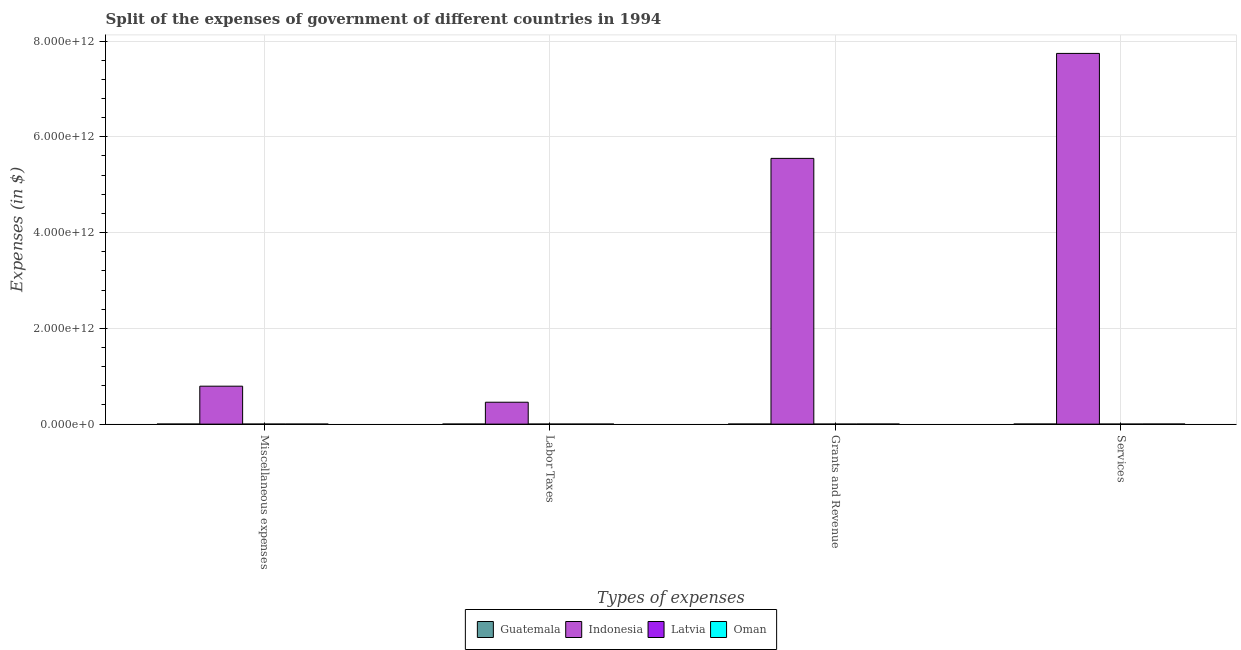How many different coloured bars are there?
Your answer should be compact. 4. How many groups of bars are there?
Offer a very short reply. 4. Are the number of bars per tick equal to the number of legend labels?
Give a very brief answer. Yes. Are the number of bars on each tick of the X-axis equal?
Your answer should be very brief. Yes. What is the label of the 3rd group of bars from the left?
Offer a very short reply. Grants and Revenue. What is the amount spent on grants and revenue in Guatemala?
Your response must be concise. 5.42e+08. Across all countries, what is the maximum amount spent on grants and revenue?
Offer a terse response. 5.55e+12. Across all countries, what is the minimum amount spent on labor taxes?
Offer a terse response. 1.20e+05. In which country was the amount spent on grants and revenue maximum?
Provide a succinct answer. Indonesia. In which country was the amount spent on services minimum?
Provide a short and direct response. Latvia. What is the total amount spent on labor taxes in the graph?
Make the answer very short. 4.57e+11. What is the difference between the amount spent on services in Latvia and that in Indonesia?
Offer a very short reply. -7.74e+12. What is the difference between the amount spent on miscellaneous expenses in Oman and the amount spent on grants and revenue in Guatemala?
Provide a short and direct response. -5.33e+08. What is the average amount spent on miscellaneous expenses per country?
Give a very brief answer. 1.98e+11. What is the difference between the amount spent on grants and revenue and amount spent on labor taxes in Latvia?
Ensure brevity in your answer.  3.44e+07. What is the ratio of the amount spent on services in Indonesia to that in Oman?
Provide a short and direct response. 8257.95. Is the amount spent on miscellaneous expenses in Oman less than that in Indonesia?
Offer a very short reply. Yes. What is the difference between the highest and the second highest amount spent on grants and revenue?
Your answer should be very brief. 5.55e+12. What is the difference between the highest and the lowest amount spent on services?
Your answer should be compact. 7.74e+12. In how many countries, is the amount spent on miscellaneous expenses greater than the average amount spent on miscellaneous expenses taken over all countries?
Ensure brevity in your answer.  1. Is the sum of the amount spent on grants and revenue in Indonesia and Oman greater than the maximum amount spent on miscellaneous expenses across all countries?
Your answer should be compact. Yes. What does the 1st bar from the left in Grants and Revenue represents?
Provide a succinct answer. Guatemala. Is it the case that in every country, the sum of the amount spent on miscellaneous expenses and amount spent on labor taxes is greater than the amount spent on grants and revenue?
Give a very brief answer. No. How many bars are there?
Ensure brevity in your answer.  16. What is the difference between two consecutive major ticks on the Y-axis?
Provide a succinct answer. 2.00e+12. How many legend labels are there?
Give a very brief answer. 4. How are the legend labels stacked?
Provide a short and direct response. Horizontal. What is the title of the graph?
Ensure brevity in your answer.  Split of the expenses of government of different countries in 1994. Does "Venezuela" appear as one of the legend labels in the graph?
Your answer should be compact. No. What is the label or title of the X-axis?
Keep it short and to the point. Types of expenses. What is the label or title of the Y-axis?
Ensure brevity in your answer.  Expenses (in $). What is the Expenses (in $) of Guatemala in Miscellaneous expenses?
Offer a terse response. 4.79e+08. What is the Expenses (in $) in Indonesia in Miscellaneous expenses?
Make the answer very short. 7.92e+11. What is the Expenses (in $) in Latvia in Miscellaneous expenses?
Offer a very short reply. 2.86e+06. What is the Expenses (in $) of Oman in Miscellaneous expenses?
Your response must be concise. 8.50e+06. What is the Expenses (in $) in Guatemala in Labor Taxes?
Provide a short and direct response. 2.20e+08. What is the Expenses (in $) in Indonesia in Labor Taxes?
Offer a terse response. 4.57e+11. What is the Expenses (in $) of Oman in Labor Taxes?
Ensure brevity in your answer.  1.62e+07. What is the Expenses (in $) of Guatemala in Grants and Revenue?
Provide a succinct answer. 5.42e+08. What is the Expenses (in $) in Indonesia in Grants and Revenue?
Provide a short and direct response. 5.55e+12. What is the Expenses (in $) of Latvia in Grants and Revenue?
Your response must be concise. 3.46e+07. What is the Expenses (in $) in Oman in Grants and Revenue?
Give a very brief answer. 1.06e+09. What is the Expenses (in $) of Guatemala in Services?
Offer a very short reply. 8.14e+08. What is the Expenses (in $) in Indonesia in Services?
Keep it short and to the point. 7.74e+12. What is the Expenses (in $) in Latvia in Services?
Offer a terse response. 9.75e+07. What is the Expenses (in $) of Oman in Services?
Provide a short and direct response. 9.37e+08. Across all Types of expenses, what is the maximum Expenses (in $) in Guatemala?
Provide a succinct answer. 8.14e+08. Across all Types of expenses, what is the maximum Expenses (in $) in Indonesia?
Your response must be concise. 7.74e+12. Across all Types of expenses, what is the maximum Expenses (in $) of Latvia?
Make the answer very short. 9.75e+07. Across all Types of expenses, what is the maximum Expenses (in $) of Oman?
Offer a very short reply. 1.06e+09. Across all Types of expenses, what is the minimum Expenses (in $) of Guatemala?
Give a very brief answer. 2.20e+08. Across all Types of expenses, what is the minimum Expenses (in $) of Indonesia?
Make the answer very short. 4.57e+11. Across all Types of expenses, what is the minimum Expenses (in $) of Latvia?
Ensure brevity in your answer.  1.20e+05. Across all Types of expenses, what is the minimum Expenses (in $) in Oman?
Your response must be concise. 8.50e+06. What is the total Expenses (in $) of Guatemala in the graph?
Give a very brief answer. 2.05e+09. What is the total Expenses (in $) of Indonesia in the graph?
Offer a terse response. 1.45e+13. What is the total Expenses (in $) in Latvia in the graph?
Give a very brief answer. 1.35e+08. What is the total Expenses (in $) in Oman in the graph?
Your response must be concise. 2.02e+09. What is the difference between the Expenses (in $) of Guatemala in Miscellaneous expenses and that in Labor Taxes?
Your answer should be very brief. 2.59e+08. What is the difference between the Expenses (in $) of Indonesia in Miscellaneous expenses and that in Labor Taxes?
Ensure brevity in your answer.  3.35e+11. What is the difference between the Expenses (in $) of Latvia in Miscellaneous expenses and that in Labor Taxes?
Ensure brevity in your answer.  2.74e+06. What is the difference between the Expenses (in $) in Oman in Miscellaneous expenses and that in Labor Taxes?
Ensure brevity in your answer.  -7.70e+06. What is the difference between the Expenses (in $) of Guatemala in Miscellaneous expenses and that in Grants and Revenue?
Make the answer very short. -6.28e+07. What is the difference between the Expenses (in $) of Indonesia in Miscellaneous expenses and that in Grants and Revenue?
Keep it short and to the point. -4.76e+12. What is the difference between the Expenses (in $) in Latvia in Miscellaneous expenses and that in Grants and Revenue?
Offer a terse response. -3.17e+07. What is the difference between the Expenses (in $) in Oman in Miscellaneous expenses and that in Grants and Revenue?
Offer a very short reply. -1.05e+09. What is the difference between the Expenses (in $) of Guatemala in Miscellaneous expenses and that in Services?
Your response must be concise. -3.35e+08. What is the difference between the Expenses (in $) of Indonesia in Miscellaneous expenses and that in Services?
Ensure brevity in your answer.  -6.95e+12. What is the difference between the Expenses (in $) in Latvia in Miscellaneous expenses and that in Services?
Make the answer very short. -9.46e+07. What is the difference between the Expenses (in $) in Oman in Miscellaneous expenses and that in Services?
Offer a terse response. -9.29e+08. What is the difference between the Expenses (in $) of Guatemala in Labor Taxes and that in Grants and Revenue?
Give a very brief answer. -3.22e+08. What is the difference between the Expenses (in $) in Indonesia in Labor Taxes and that in Grants and Revenue?
Provide a succinct answer. -5.09e+12. What is the difference between the Expenses (in $) of Latvia in Labor Taxes and that in Grants and Revenue?
Provide a succinct answer. -3.44e+07. What is the difference between the Expenses (in $) of Oman in Labor Taxes and that in Grants and Revenue?
Provide a succinct answer. -1.04e+09. What is the difference between the Expenses (in $) in Guatemala in Labor Taxes and that in Services?
Ensure brevity in your answer.  -5.94e+08. What is the difference between the Expenses (in $) of Indonesia in Labor Taxes and that in Services?
Keep it short and to the point. -7.28e+12. What is the difference between the Expenses (in $) in Latvia in Labor Taxes and that in Services?
Your response must be concise. -9.74e+07. What is the difference between the Expenses (in $) in Oman in Labor Taxes and that in Services?
Offer a very short reply. -9.21e+08. What is the difference between the Expenses (in $) in Guatemala in Grants and Revenue and that in Services?
Give a very brief answer. -2.72e+08. What is the difference between the Expenses (in $) of Indonesia in Grants and Revenue and that in Services?
Your response must be concise. -2.19e+12. What is the difference between the Expenses (in $) of Latvia in Grants and Revenue and that in Services?
Keep it short and to the point. -6.29e+07. What is the difference between the Expenses (in $) in Oman in Grants and Revenue and that in Services?
Your answer should be very brief. 1.19e+08. What is the difference between the Expenses (in $) of Guatemala in Miscellaneous expenses and the Expenses (in $) of Indonesia in Labor Taxes?
Make the answer very short. -4.57e+11. What is the difference between the Expenses (in $) in Guatemala in Miscellaneous expenses and the Expenses (in $) in Latvia in Labor Taxes?
Your answer should be very brief. 4.79e+08. What is the difference between the Expenses (in $) of Guatemala in Miscellaneous expenses and the Expenses (in $) of Oman in Labor Taxes?
Provide a succinct answer. 4.63e+08. What is the difference between the Expenses (in $) in Indonesia in Miscellaneous expenses and the Expenses (in $) in Latvia in Labor Taxes?
Your response must be concise. 7.92e+11. What is the difference between the Expenses (in $) of Indonesia in Miscellaneous expenses and the Expenses (in $) of Oman in Labor Taxes?
Offer a terse response. 7.92e+11. What is the difference between the Expenses (in $) of Latvia in Miscellaneous expenses and the Expenses (in $) of Oman in Labor Taxes?
Give a very brief answer. -1.33e+07. What is the difference between the Expenses (in $) of Guatemala in Miscellaneous expenses and the Expenses (in $) of Indonesia in Grants and Revenue?
Your answer should be compact. -5.55e+12. What is the difference between the Expenses (in $) of Guatemala in Miscellaneous expenses and the Expenses (in $) of Latvia in Grants and Revenue?
Provide a short and direct response. 4.44e+08. What is the difference between the Expenses (in $) of Guatemala in Miscellaneous expenses and the Expenses (in $) of Oman in Grants and Revenue?
Your answer should be very brief. -5.77e+08. What is the difference between the Expenses (in $) in Indonesia in Miscellaneous expenses and the Expenses (in $) in Latvia in Grants and Revenue?
Give a very brief answer. 7.92e+11. What is the difference between the Expenses (in $) of Indonesia in Miscellaneous expenses and the Expenses (in $) of Oman in Grants and Revenue?
Your response must be concise. 7.91e+11. What is the difference between the Expenses (in $) in Latvia in Miscellaneous expenses and the Expenses (in $) in Oman in Grants and Revenue?
Give a very brief answer. -1.05e+09. What is the difference between the Expenses (in $) in Guatemala in Miscellaneous expenses and the Expenses (in $) in Indonesia in Services?
Your answer should be compact. -7.74e+12. What is the difference between the Expenses (in $) of Guatemala in Miscellaneous expenses and the Expenses (in $) of Latvia in Services?
Your answer should be very brief. 3.82e+08. What is the difference between the Expenses (in $) of Guatemala in Miscellaneous expenses and the Expenses (in $) of Oman in Services?
Keep it short and to the point. -4.58e+08. What is the difference between the Expenses (in $) of Indonesia in Miscellaneous expenses and the Expenses (in $) of Latvia in Services?
Give a very brief answer. 7.92e+11. What is the difference between the Expenses (in $) of Indonesia in Miscellaneous expenses and the Expenses (in $) of Oman in Services?
Provide a succinct answer. 7.91e+11. What is the difference between the Expenses (in $) of Latvia in Miscellaneous expenses and the Expenses (in $) of Oman in Services?
Offer a very short reply. -9.35e+08. What is the difference between the Expenses (in $) of Guatemala in Labor Taxes and the Expenses (in $) of Indonesia in Grants and Revenue?
Keep it short and to the point. -5.55e+12. What is the difference between the Expenses (in $) in Guatemala in Labor Taxes and the Expenses (in $) in Latvia in Grants and Revenue?
Provide a succinct answer. 1.85e+08. What is the difference between the Expenses (in $) in Guatemala in Labor Taxes and the Expenses (in $) in Oman in Grants and Revenue?
Offer a terse response. -8.36e+08. What is the difference between the Expenses (in $) in Indonesia in Labor Taxes and the Expenses (in $) in Latvia in Grants and Revenue?
Your answer should be very brief. 4.57e+11. What is the difference between the Expenses (in $) of Indonesia in Labor Taxes and the Expenses (in $) of Oman in Grants and Revenue?
Give a very brief answer. 4.56e+11. What is the difference between the Expenses (in $) of Latvia in Labor Taxes and the Expenses (in $) of Oman in Grants and Revenue?
Your response must be concise. -1.06e+09. What is the difference between the Expenses (in $) in Guatemala in Labor Taxes and the Expenses (in $) in Indonesia in Services?
Offer a terse response. -7.74e+12. What is the difference between the Expenses (in $) in Guatemala in Labor Taxes and the Expenses (in $) in Latvia in Services?
Your answer should be compact. 1.23e+08. What is the difference between the Expenses (in $) of Guatemala in Labor Taxes and the Expenses (in $) of Oman in Services?
Offer a very short reply. -7.17e+08. What is the difference between the Expenses (in $) of Indonesia in Labor Taxes and the Expenses (in $) of Latvia in Services?
Your response must be concise. 4.57e+11. What is the difference between the Expenses (in $) in Indonesia in Labor Taxes and the Expenses (in $) in Oman in Services?
Ensure brevity in your answer.  4.56e+11. What is the difference between the Expenses (in $) of Latvia in Labor Taxes and the Expenses (in $) of Oman in Services?
Provide a short and direct response. -9.37e+08. What is the difference between the Expenses (in $) of Guatemala in Grants and Revenue and the Expenses (in $) of Indonesia in Services?
Offer a very short reply. -7.74e+12. What is the difference between the Expenses (in $) of Guatemala in Grants and Revenue and the Expenses (in $) of Latvia in Services?
Offer a very short reply. 4.44e+08. What is the difference between the Expenses (in $) in Guatemala in Grants and Revenue and the Expenses (in $) in Oman in Services?
Ensure brevity in your answer.  -3.95e+08. What is the difference between the Expenses (in $) of Indonesia in Grants and Revenue and the Expenses (in $) of Latvia in Services?
Ensure brevity in your answer.  5.55e+12. What is the difference between the Expenses (in $) of Indonesia in Grants and Revenue and the Expenses (in $) of Oman in Services?
Make the answer very short. 5.55e+12. What is the difference between the Expenses (in $) in Latvia in Grants and Revenue and the Expenses (in $) in Oman in Services?
Ensure brevity in your answer.  -9.03e+08. What is the average Expenses (in $) in Guatemala per Types of expenses?
Make the answer very short. 5.14e+08. What is the average Expenses (in $) in Indonesia per Types of expenses?
Provide a succinct answer. 3.63e+12. What is the average Expenses (in $) in Latvia per Types of expenses?
Ensure brevity in your answer.  3.38e+07. What is the average Expenses (in $) in Oman per Types of expenses?
Keep it short and to the point. 5.05e+08. What is the difference between the Expenses (in $) of Guatemala and Expenses (in $) of Indonesia in Miscellaneous expenses?
Make the answer very short. -7.92e+11. What is the difference between the Expenses (in $) of Guatemala and Expenses (in $) of Latvia in Miscellaneous expenses?
Your answer should be compact. 4.76e+08. What is the difference between the Expenses (in $) in Guatemala and Expenses (in $) in Oman in Miscellaneous expenses?
Make the answer very short. 4.71e+08. What is the difference between the Expenses (in $) of Indonesia and Expenses (in $) of Latvia in Miscellaneous expenses?
Give a very brief answer. 7.92e+11. What is the difference between the Expenses (in $) in Indonesia and Expenses (in $) in Oman in Miscellaneous expenses?
Your answer should be very brief. 7.92e+11. What is the difference between the Expenses (in $) in Latvia and Expenses (in $) in Oman in Miscellaneous expenses?
Ensure brevity in your answer.  -5.64e+06. What is the difference between the Expenses (in $) of Guatemala and Expenses (in $) of Indonesia in Labor Taxes?
Keep it short and to the point. -4.57e+11. What is the difference between the Expenses (in $) of Guatemala and Expenses (in $) of Latvia in Labor Taxes?
Your response must be concise. 2.20e+08. What is the difference between the Expenses (in $) in Guatemala and Expenses (in $) in Oman in Labor Taxes?
Ensure brevity in your answer.  2.04e+08. What is the difference between the Expenses (in $) in Indonesia and Expenses (in $) in Latvia in Labor Taxes?
Give a very brief answer. 4.57e+11. What is the difference between the Expenses (in $) of Indonesia and Expenses (in $) of Oman in Labor Taxes?
Offer a terse response. 4.57e+11. What is the difference between the Expenses (in $) in Latvia and Expenses (in $) in Oman in Labor Taxes?
Give a very brief answer. -1.61e+07. What is the difference between the Expenses (in $) of Guatemala and Expenses (in $) of Indonesia in Grants and Revenue?
Keep it short and to the point. -5.55e+12. What is the difference between the Expenses (in $) in Guatemala and Expenses (in $) in Latvia in Grants and Revenue?
Provide a succinct answer. 5.07e+08. What is the difference between the Expenses (in $) of Guatemala and Expenses (in $) of Oman in Grants and Revenue?
Your response must be concise. -5.14e+08. What is the difference between the Expenses (in $) in Indonesia and Expenses (in $) in Latvia in Grants and Revenue?
Offer a terse response. 5.55e+12. What is the difference between the Expenses (in $) in Indonesia and Expenses (in $) in Oman in Grants and Revenue?
Your response must be concise. 5.55e+12. What is the difference between the Expenses (in $) in Latvia and Expenses (in $) in Oman in Grants and Revenue?
Keep it short and to the point. -1.02e+09. What is the difference between the Expenses (in $) in Guatemala and Expenses (in $) in Indonesia in Services?
Offer a terse response. -7.74e+12. What is the difference between the Expenses (in $) in Guatemala and Expenses (in $) in Latvia in Services?
Give a very brief answer. 7.16e+08. What is the difference between the Expenses (in $) of Guatemala and Expenses (in $) of Oman in Services?
Keep it short and to the point. -1.24e+08. What is the difference between the Expenses (in $) of Indonesia and Expenses (in $) of Latvia in Services?
Provide a succinct answer. 7.74e+12. What is the difference between the Expenses (in $) in Indonesia and Expenses (in $) in Oman in Services?
Provide a succinct answer. 7.74e+12. What is the difference between the Expenses (in $) in Latvia and Expenses (in $) in Oman in Services?
Give a very brief answer. -8.40e+08. What is the ratio of the Expenses (in $) of Guatemala in Miscellaneous expenses to that in Labor Taxes?
Your answer should be very brief. 2.18. What is the ratio of the Expenses (in $) of Indonesia in Miscellaneous expenses to that in Labor Taxes?
Offer a very short reply. 1.73. What is the ratio of the Expenses (in $) in Latvia in Miscellaneous expenses to that in Labor Taxes?
Your response must be concise. 23.83. What is the ratio of the Expenses (in $) of Oman in Miscellaneous expenses to that in Labor Taxes?
Offer a terse response. 0.52. What is the ratio of the Expenses (in $) in Guatemala in Miscellaneous expenses to that in Grants and Revenue?
Your response must be concise. 0.88. What is the ratio of the Expenses (in $) in Indonesia in Miscellaneous expenses to that in Grants and Revenue?
Your answer should be very brief. 0.14. What is the ratio of the Expenses (in $) of Latvia in Miscellaneous expenses to that in Grants and Revenue?
Make the answer very short. 0.08. What is the ratio of the Expenses (in $) in Oman in Miscellaneous expenses to that in Grants and Revenue?
Provide a short and direct response. 0.01. What is the ratio of the Expenses (in $) of Guatemala in Miscellaneous expenses to that in Services?
Give a very brief answer. 0.59. What is the ratio of the Expenses (in $) of Indonesia in Miscellaneous expenses to that in Services?
Keep it short and to the point. 0.1. What is the ratio of the Expenses (in $) in Latvia in Miscellaneous expenses to that in Services?
Your answer should be compact. 0.03. What is the ratio of the Expenses (in $) in Oman in Miscellaneous expenses to that in Services?
Your response must be concise. 0.01. What is the ratio of the Expenses (in $) of Guatemala in Labor Taxes to that in Grants and Revenue?
Your response must be concise. 0.41. What is the ratio of the Expenses (in $) of Indonesia in Labor Taxes to that in Grants and Revenue?
Ensure brevity in your answer.  0.08. What is the ratio of the Expenses (in $) of Latvia in Labor Taxes to that in Grants and Revenue?
Provide a succinct answer. 0. What is the ratio of the Expenses (in $) of Oman in Labor Taxes to that in Grants and Revenue?
Keep it short and to the point. 0.02. What is the ratio of the Expenses (in $) of Guatemala in Labor Taxes to that in Services?
Ensure brevity in your answer.  0.27. What is the ratio of the Expenses (in $) in Indonesia in Labor Taxes to that in Services?
Keep it short and to the point. 0.06. What is the ratio of the Expenses (in $) in Latvia in Labor Taxes to that in Services?
Provide a short and direct response. 0. What is the ratio of the Expenses (in $) of Oman in Labor Taxes to that in Services?
Ensure brevity in your answer.  0.02. What is the ratio of the Expenses (in $) in Guatemala in Grants and Revenue to that in Services?
Offer a very short reply. 0.67. What is the ratio of the Expenses (in $) of Indonesia in Grants and Revenue to that in Services?
Keep it short and to the point. 0.72. What is the ratio of the Expenses (in $) in Latvia in Grants and Revenue to that in Services?
Ensure brevity in your answer.  0.35. What is the ratio of the Expenses (in $) of Oman in Grants and Revenue to that in Services?
Provide a succinct answer. 1.13. What is the difference between the highest and the second highest Expenses (in $) in Guatemala?
Keep it short and to the point. 2.72e+08. What is the difference between the highest and the second highest Expenses (in $) in Indonesia?
Ensure brevity in your answer.  2.19e+12. What is the difference between the highest and the second highest Expenses (in $) of Latvia?
Your answer should be very brief. 6.29e+07. What is the difference between the highest and the second highest Expenses (in $) in Oman?
Give a very brief answer. 1.19e+08. What is the difference between the highest and the lowest Expenses (in $) in Guatemala?
Provide a short and direct response. 5.94e+08. What is the difference between the highest and the lowest Expenses (in $) of Indonesia?
Your answer should be compact. 7.28e+12. What is the difference between the highest and the lowest Expenses (in $) in Latvia?
Ensure brevity in your answer.  9.74e+07. What is the difference between the highest and the lowest Expenses (in $) in Oman?
Keep it short and to the point. 1.05e+09. 